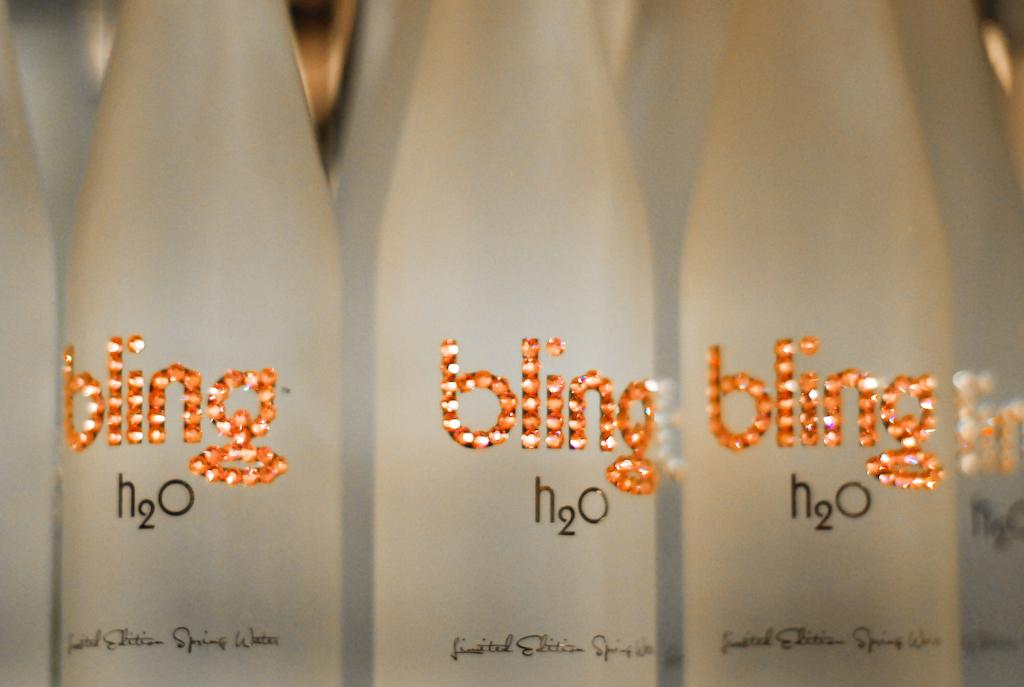What kind of drink is in these bottle?
Your answer should be compact. Water. Who made these drinks?
Your response must be concise. Bling. 